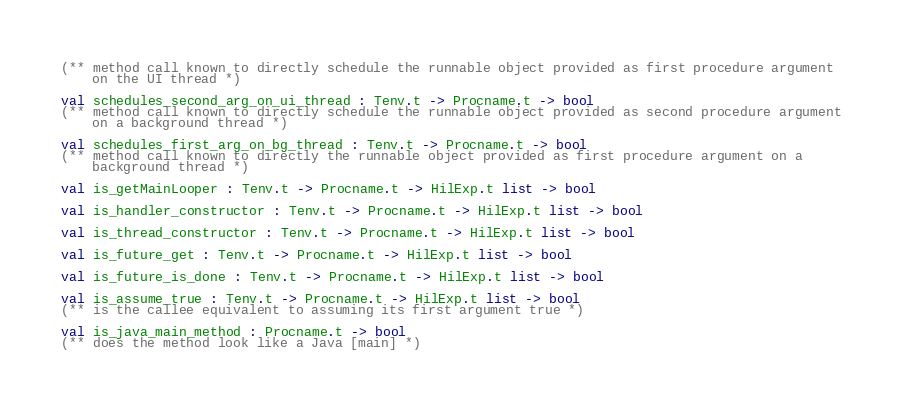<code> <loc_0><loc_0><loc_500><loc_500><_OCaml_>(** method call known to directly schedule the runnable object provided as first procedure argument
    on the UI thread *)

val schedules_second_arg_on_ui_thread : Tenv.t -> Procname.t -> bool
(** method call known to directly schedule the runnable object provided as second procedure argument
    on a background thread *)

val schedules_first_arg_on_bg_thread : Tenv.t -> Procname.t -> bool
(** method call known to directly the runnable object provided as first procedure argument on a
    background thread *)

val is_getMainLooper : Tenv.t -> Procname.t -> HilExp.t list -> bool

val is_handler_constructor : Tenv.t -> Procname.t -> HilExp.t list -> bool

val is_thread_constructor : Tenv.t -> Procname.t -> HilExp.t list -> bool

val is_future_get : Tenv.t -> Procname.t -> HilExp.t list -> bool

val is_future_is_done : Tenv.t -> Procname.t -> HilExp.t list -> bool

val is_assume_true : Tenv.t -> Procname.t -> HilExp.t list -> bool
(** is the callee equivalent to assuming its first argument true *)

val is_java_main_method : Procname.t -> bool
(** does the method look like a Java [main] *)
</code> 